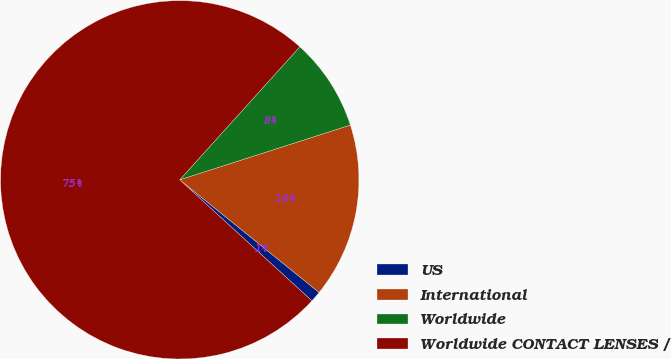Convert chart. <chart><loc_0><loc_0><loc_500><loc_500><pie_chart><fcel>US<fcel>International<fcel>Worldwide<fcel>Worldwide CONTACT LENSES /<nl><fcel>0.98%<fcel>15.76%<fcel>8.37%<fcel>74.89%<nl></chart> 